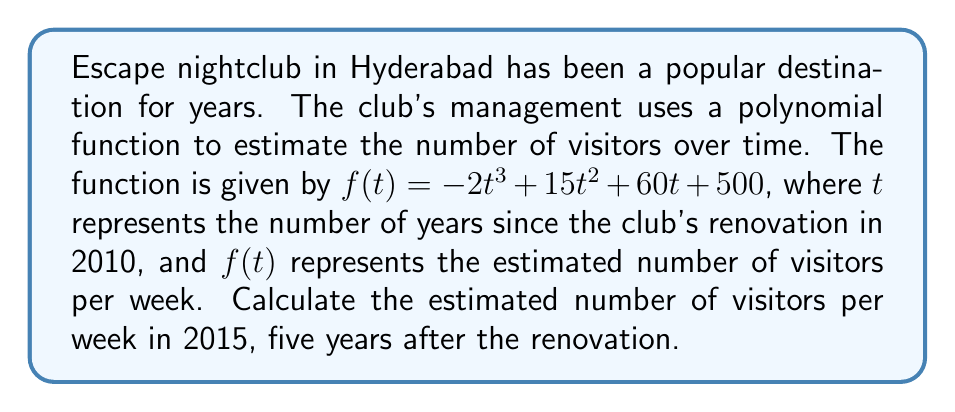What is the answer to this math problem? To solve this problem, we need to evaluate the polynomial function $f(t)$ at $t = 5$, since 2015 is 5 years after the 2010 renovation.

Let's break it down step-by-step:

1) The given function is $f(t) = -2t^3 + 15t^2 + 60t + 500$

2) We need to calculate $f(5)$

3) Substitute $t = 5$ into the function:
   $f(5) = -2(5)^3 + 15(5)^2 + 60(5) + 500$

4) Evaluate each term:
   $-2(5)^3 = -2 \cdot 125 = -250$
   $15(5)^2 = 15 \cdot 25 = 375$
   $60(5) = 300$
   $500$ remains as is

5) Sum up all the terms:
   $f(5) = -250 + 375 + 300 + 500$

6) Perform the final calculation:
   $f(5) = 925$

Therefore, the estimated number of visitors per week in 2015 is 925.
Answer: 925 visitors per week 